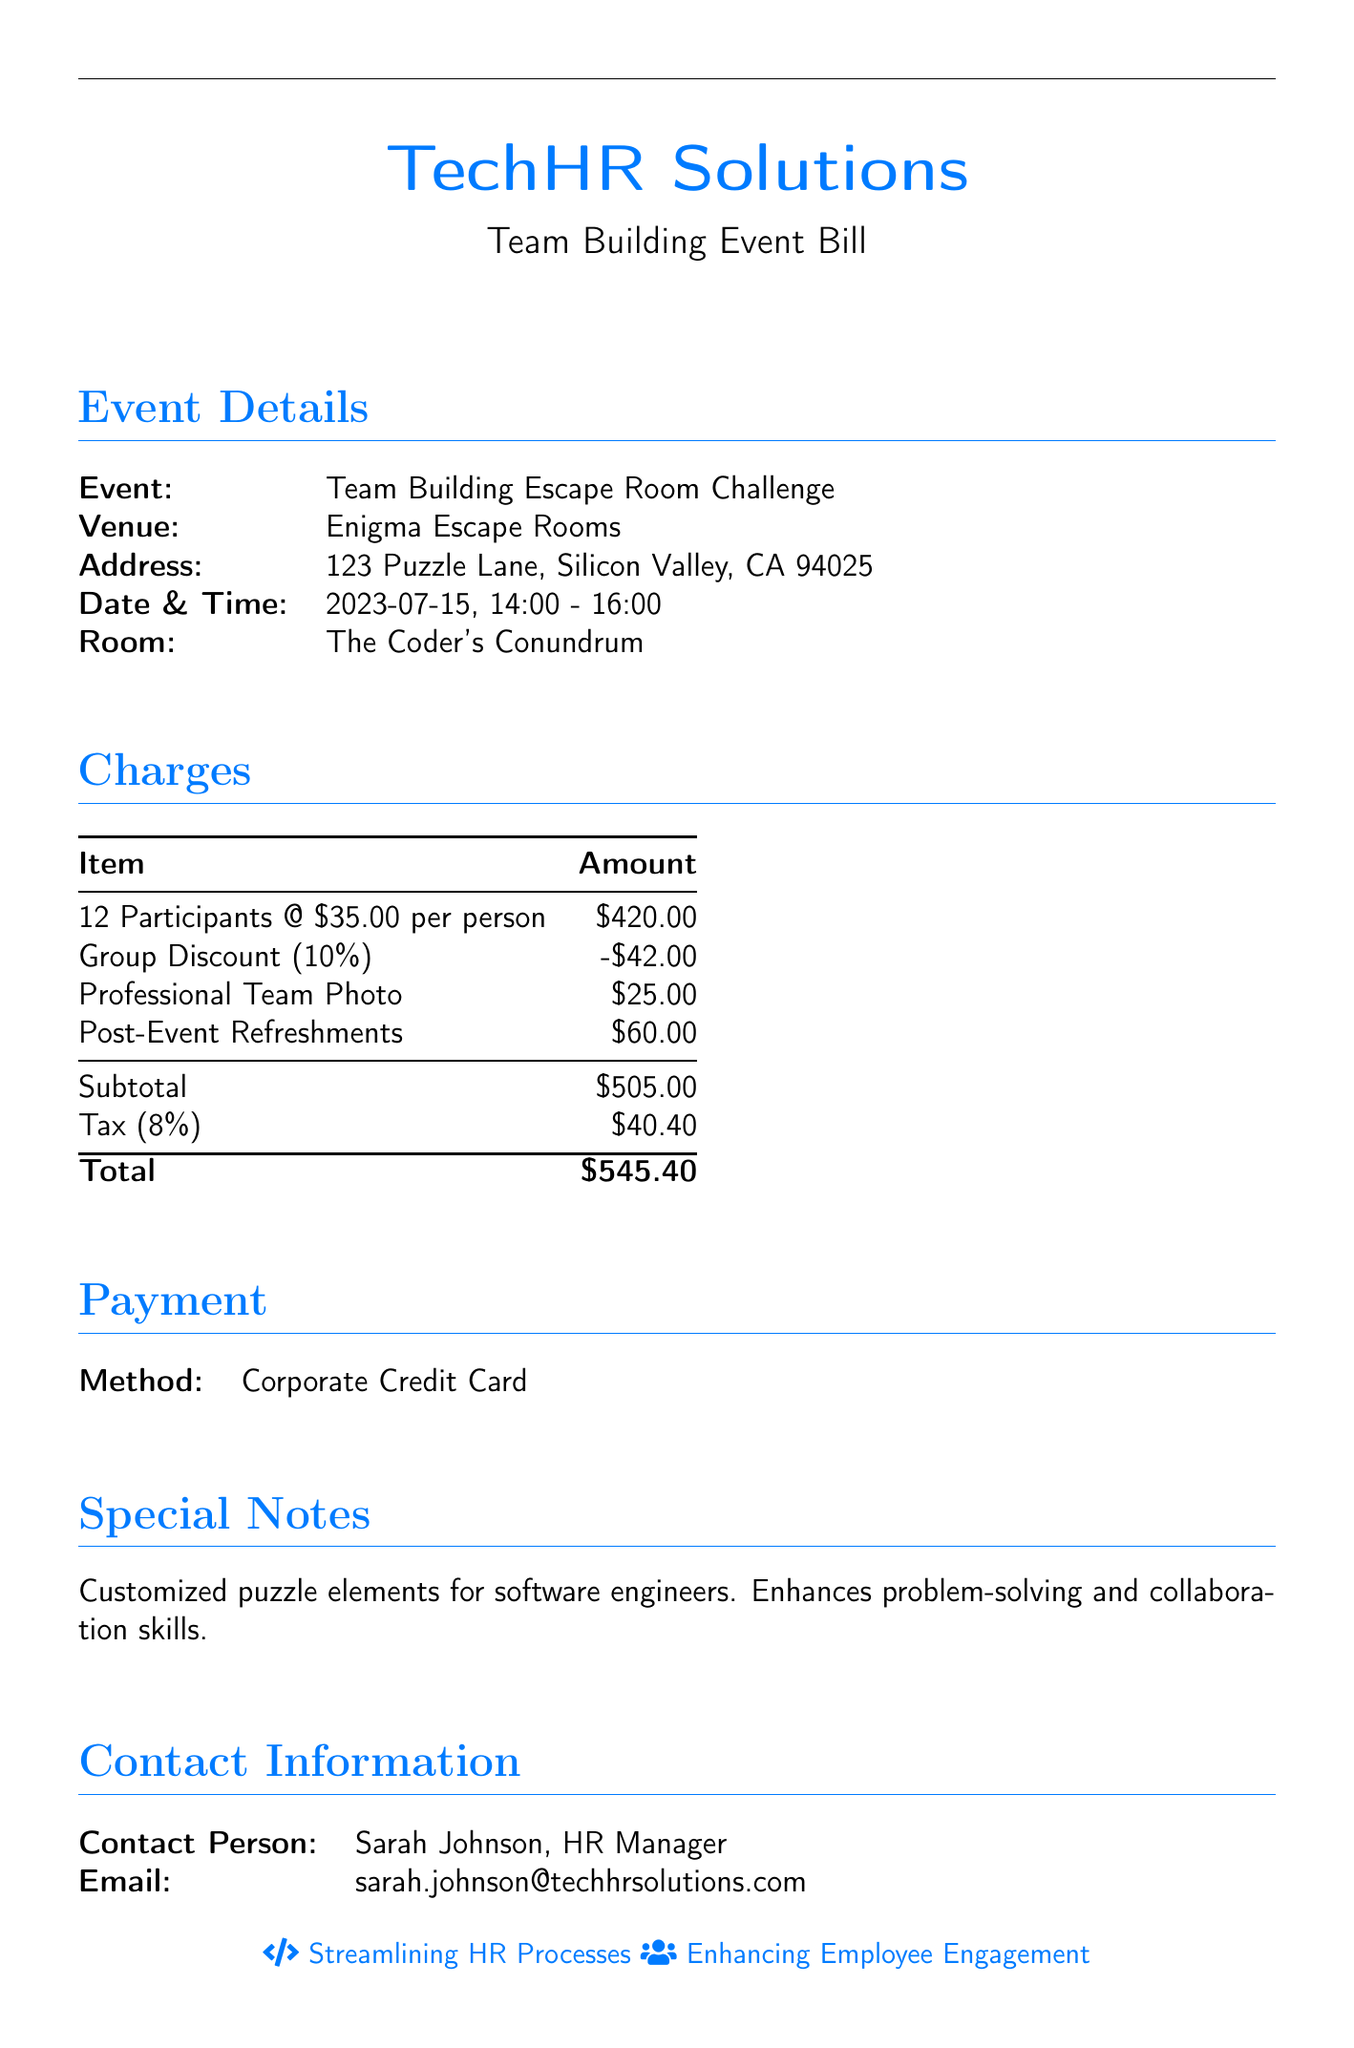what is the venue for the event? The venue is the location where the event takes place, specified in the document as Enigma Escape Rooms.
Answer: Enigma Escape Rooms who is the contact person for this bill? The contact person is the individual responsible for communication regarding this bill, identified in the document as Sarah Johnson, HR Manager.
Answer: Sarah Johnson how much is the group discount percentage? The group discount is a percentage reduction on the total charges, mentioned in the document as 10%.
Answer: 10% what is the total amount after tax? The total amount is the final sum after adding the tax to the subtotal, calculated in the document as $505.00 + $40.40.
Answer: $545.40 how many participants are there in total? The total number of participants is specified in the charges section, showing as 12 participants.
Answer: 12 what is the amount for the professional team photo? The document lists the cost for the professional team photo as a specific charge.
Answer: $25.00 what date is the team-building event scheduled for? The document provides the specific date when the event will occur, which is 2023-07-15.
Answer: 2023-07-15 what is the subtotal before tax and additional charges? The subtotal is the total amount before any tax and additional charges, listed in the document as $505.00.
Answer: $505.00 what is the purpose of the event? The event is designed for a particular activity aimed at improving team dynamics, as described in the special notes section.
Answer: Team Building Escape Room Challenge 